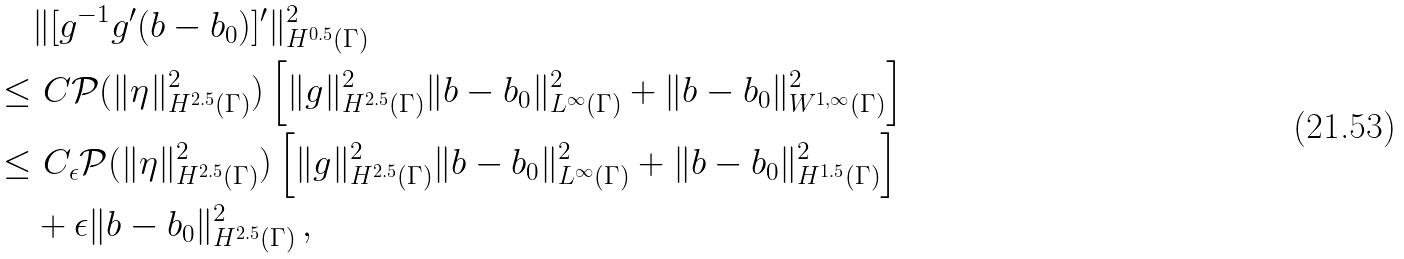Convert formula to latex. <formula><loc_0><loc_0><loc_500><loc_500>& \| [ g ^ { - 1 } g ^ { \prime } ( b - b _ { 0 } ) ] ^ { \prime } \| ^ { 2 } _ { H ^ { 0 . 5 } ( \Gamma ) } \\ \leq & \ C { \mathcal { P } } ( \| \eta \| ^ { 2 } _ { H ^ { 2 . 5 } ( \Gamma ) } ) \left [ \| g \| ^ { 2 } _ { H ^ { 2 . 5 } ( \Gamma ) } \| b - b _ { 0 } \| ^ { 2 } _ { L ^ { \infty } ( \Gamma ) } + \| b - b _ { 0 } \| ^ { 2 } _ { W ^ { 1 , \infty } ( \Gamma ) } \right ] \\ \leq & \ C _ { \epsilon } { \mathcal { P } } ( \| \eta \| ^ { 2 } _ { H ^ { 2 . 5 } ( \Gamma ) } ) \left [ \| g \| ^ { 2 } _ { H ^ { 2 . 5 } ( \Gamma ) } \| b - b _ { 0 } \| ^ { 2 } _ { L ^ { \infty } ( \Gamma ) } + \| b - b _ { 0 } \| ^ { 2 } _ { H ^ { 1 . 5 } ( \Gamma ) } \right ] \\ & + \epsilon \| b - b _ { 0 } \| ^ { 2 } _ { H ^ { 2 . 5 } ( \Gamma ) } \, ,</formula> 